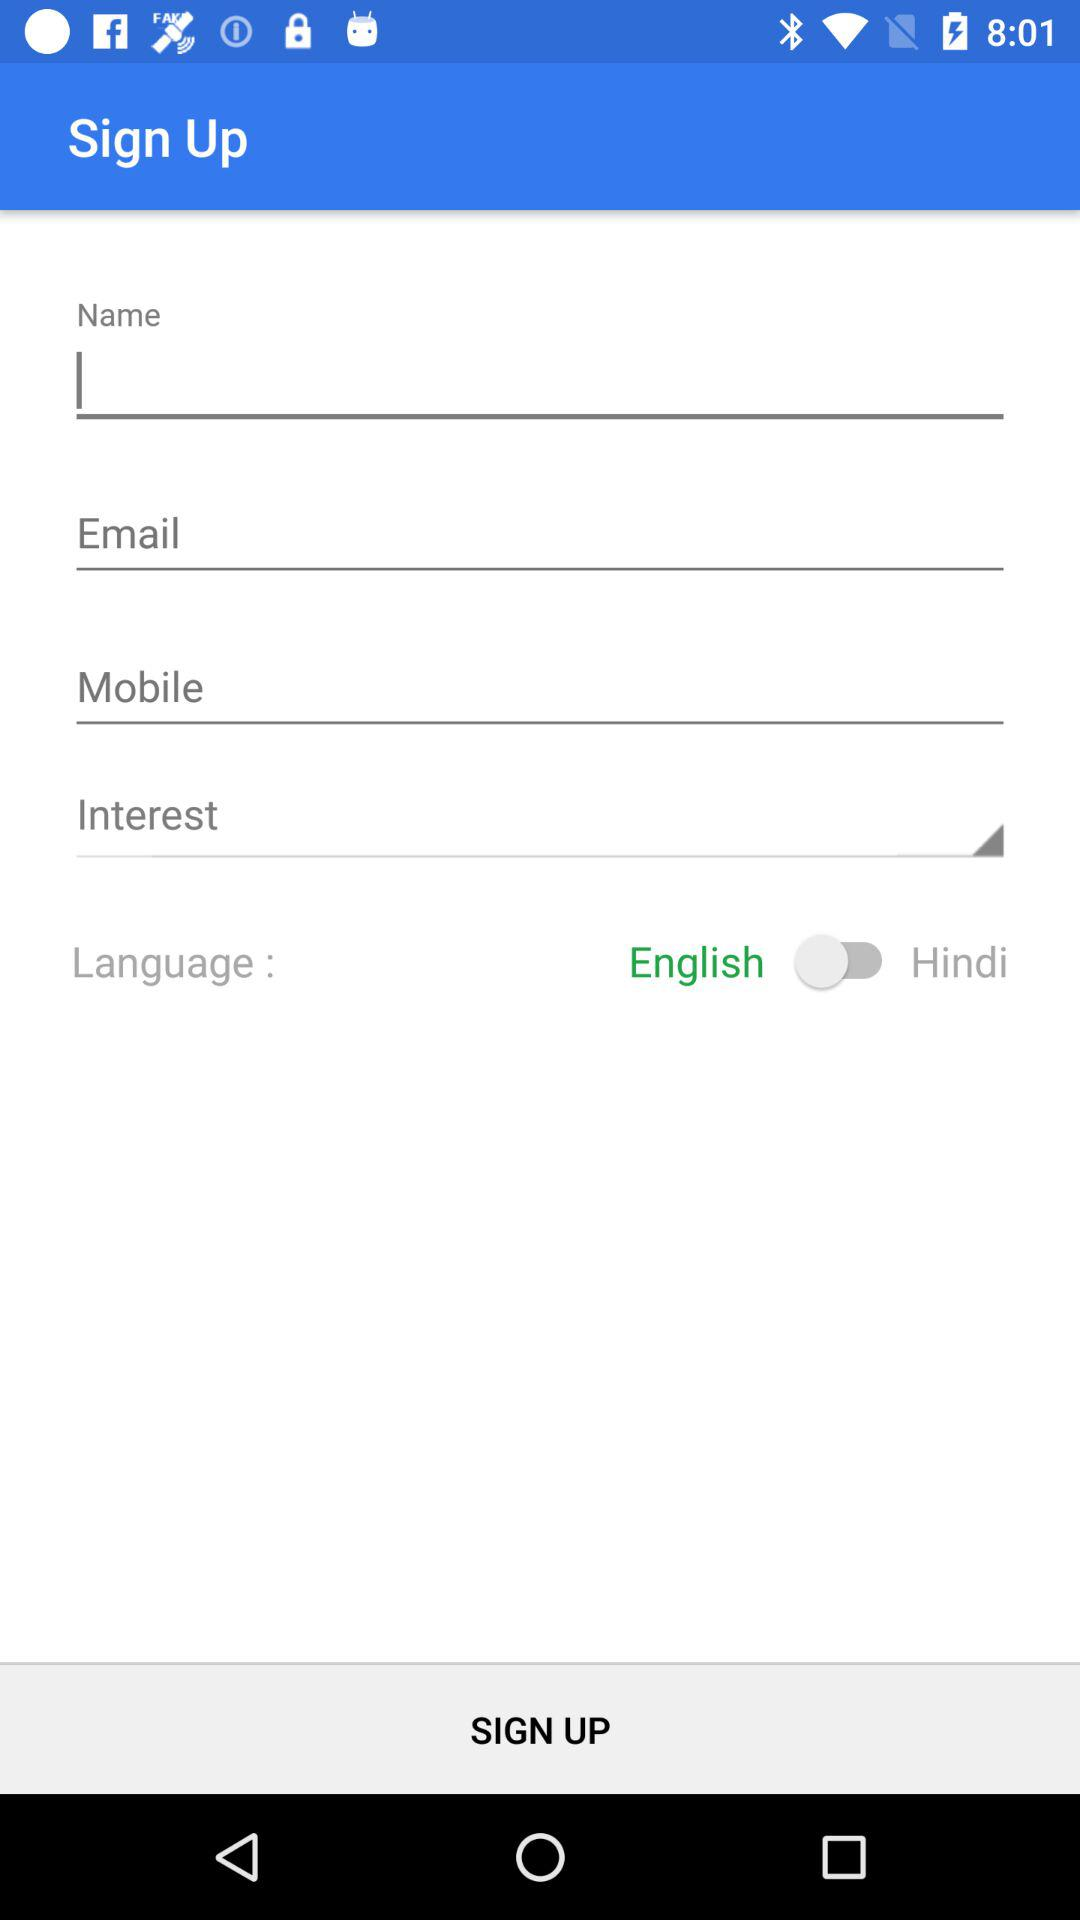What is the selected language? The selected language is English. 